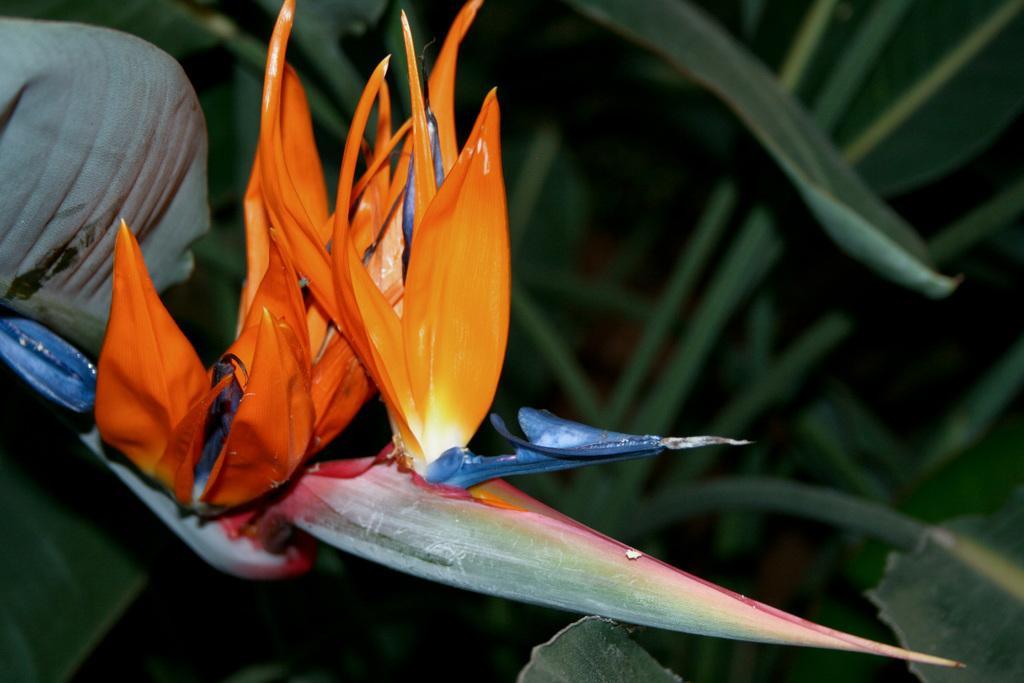In one or two sentences, can you explain what this image depicts? In this picture there are two flowers on the plant and the flowers are in orange and in violet color. At the back there are plants. 